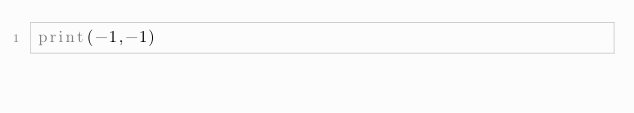<code> <loc_0><loc_0><loc_500><loc_500><_Python_>print(-1,-1)</code> 